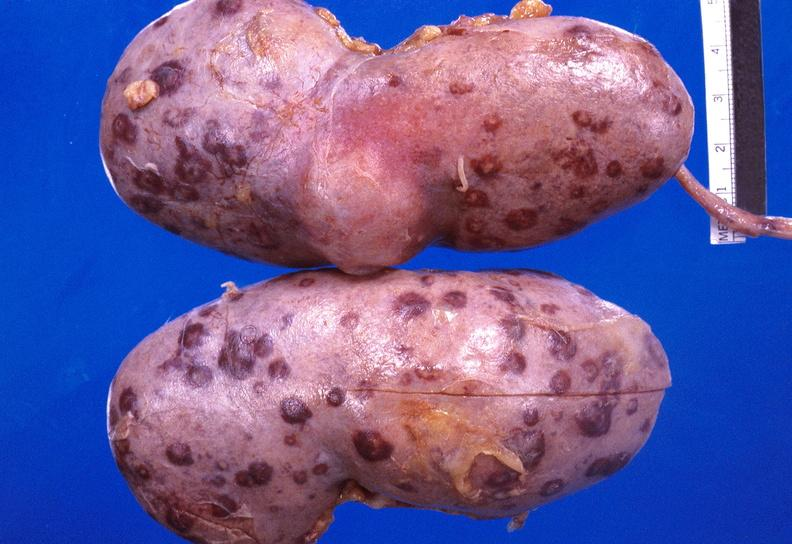where is this?
Answer the question using a single word or phrase. Urinary 